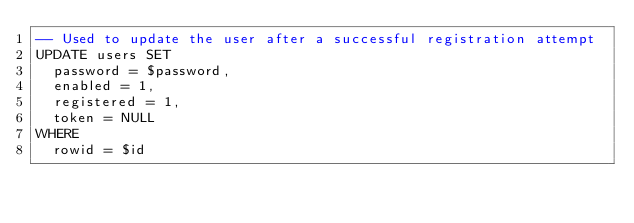Convert code to text. <code><loc_0><loc_0><loc_500><loc_500><_SQL_>-- Used to update the user after a successful registration attempt
UPDATE users SET
  password = $password,
  enabled = 1,
  registered = 1,
  token = NULL
WHERE
  rowid = $id
</code> 